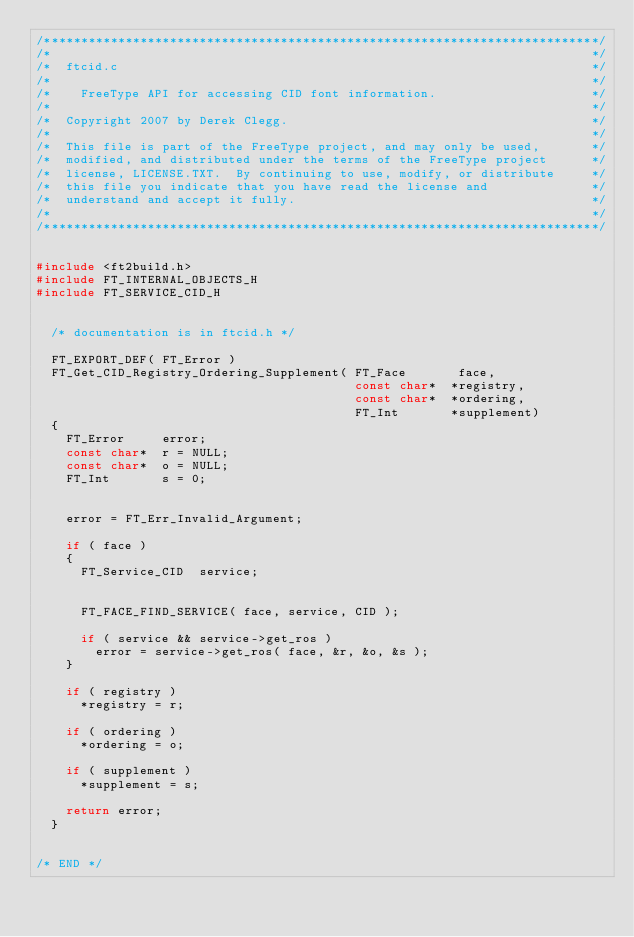<code> <loc_0><loc_0><loc_500><loc_500><_C_>/***************************************************************************/
/*                                                                         */
/*  ftcid.c                                                                */
/*                                                                         */
/*    FreeType API for accessing CID font information.                     */
/*                                                                         */
/*  Copyright 2007 by Derek Clegg.                                         */
/*                                                                         */
/*  This file is part of the FreeType project, and may only be used,       */
/*  modified, and distributed under the terms of the FreeType project      */
/*  license, LICENSE.TXT.  By continuing to use, modify, or distribute     */
/*  this file you indicate that you have read the license and              */
/*  understand and accept it fully.                                        */
/*                                                                         */
/***************************************************************************/


#include <ft2build.h>
#include FT_INTERNAL_OBJECTS_H
#include FT_SERVICE_CID_H


  /* documentation is in ftcid.h */

  FT_EXPORT_DEF( FT_Error )
  FT_Get_CID_Registry_Ordering_Supplement( FT_Face       face,
                                           const char*  *registry,
                                           const char*  *ordering,
                                           FT_Int       *supplement)
  {
    FT_Error     error;
    const char*  r = NULL;
    const char*  o = NULL;
    FT_Int       s = 0;


    error = FT_Err_Invalid_Argument;

    if ( face )
    {
      FT_Service_CID  service;


      FT_FACE_FIND_SERVICE( face, service, CID );

      if ( service && service->get_ros )
        error = service->get_ros( face, &r, &o, &s );
    }

    if ( registry )
      *registry = r;

    if ( ordering )
      *ordering = o;

    if ( supplement )
      *supplement = s;

    return error;
  }


/* END */
</code> 